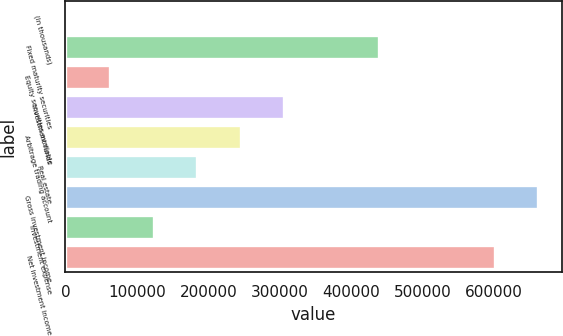Convert chart to OTSL. <chart><loc_0><loc_0><loc_500><loc_500><bar_chart><fcel>(In thousands)<fcel>Fixed maturity securities<fcel>Equity securities available<fcel>Investment funds<fcel>Arbitrage trading account<fcel>Real estate<fcel>Gross investment income<fcel>Investment expense<fcel>Net investment income<nl><fcel>2014<fcel>439489<fcel>62865.6<fcel>306272<fcel>245420<fcel>184569<fcel>661737<fcel>123717<fcel>600885<nl></chart> 